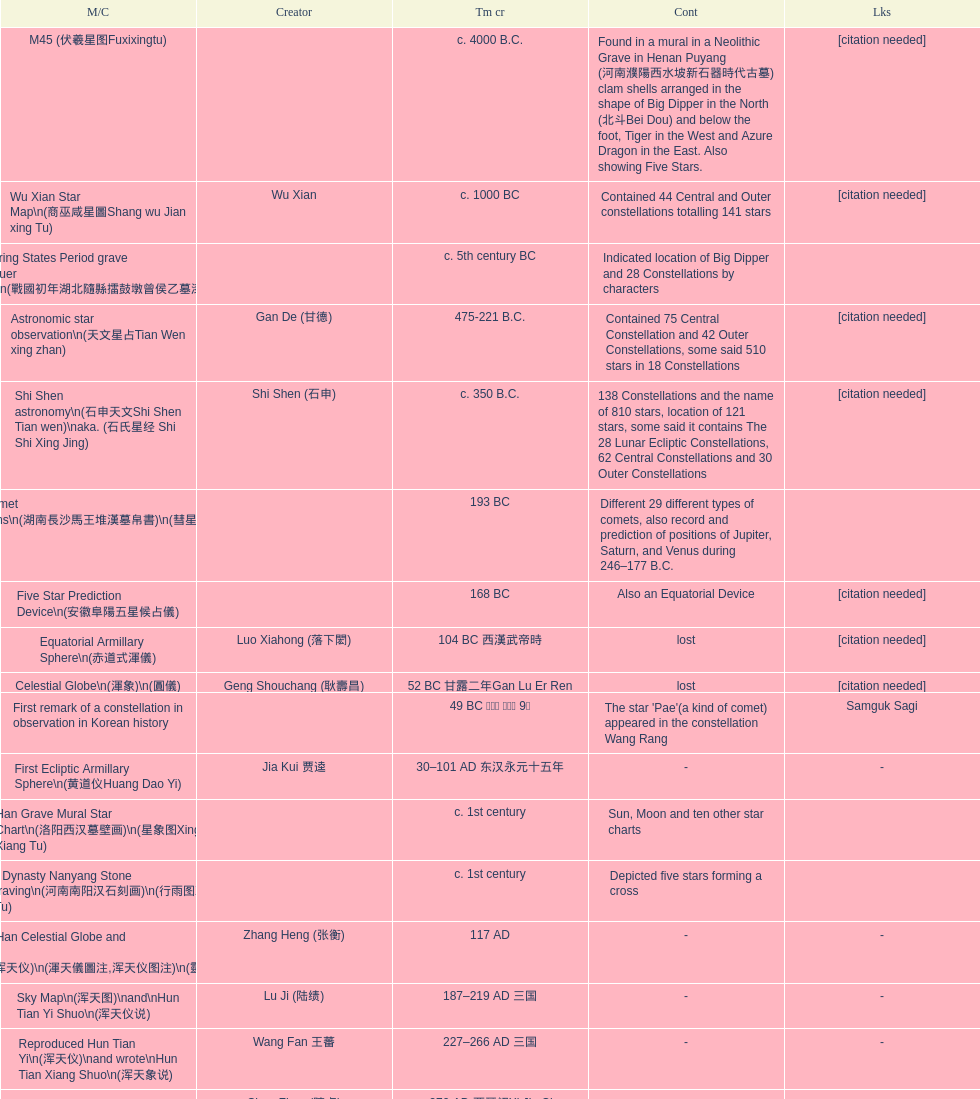Which star map was created earlier, celestial globe or the han grave mural star chart? Celestial Globe. 